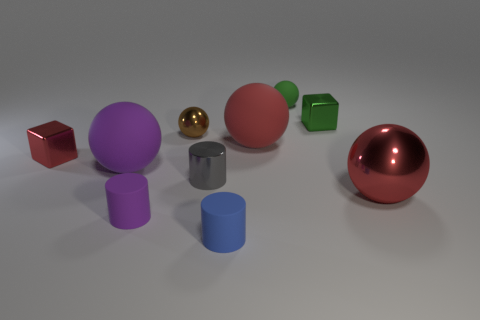Subtract all large red rubber spheres. How many spheres are left? 4 Subtract all red cylinders. How many red balls are left? 2 Subtract all red balls. How many balls are left? 3 Subtract 1 gray cylinders. How many objects are left? 9 Subtract all blocks. How many objects are left? 8 Subtract 2 blocks. How many blocks are left? 0 Subtract all cyan cubes. Subtract all blue cylinders. How many cubes are left? 2 Subtract all small blue cubes. Subtract all tiny brown objects. How many objects are left? 9 Add 7 green metallic things. How many green metallic things are left? 8 Add 8 tiny purple cubes. How many tiny purple cubes exist? 8 